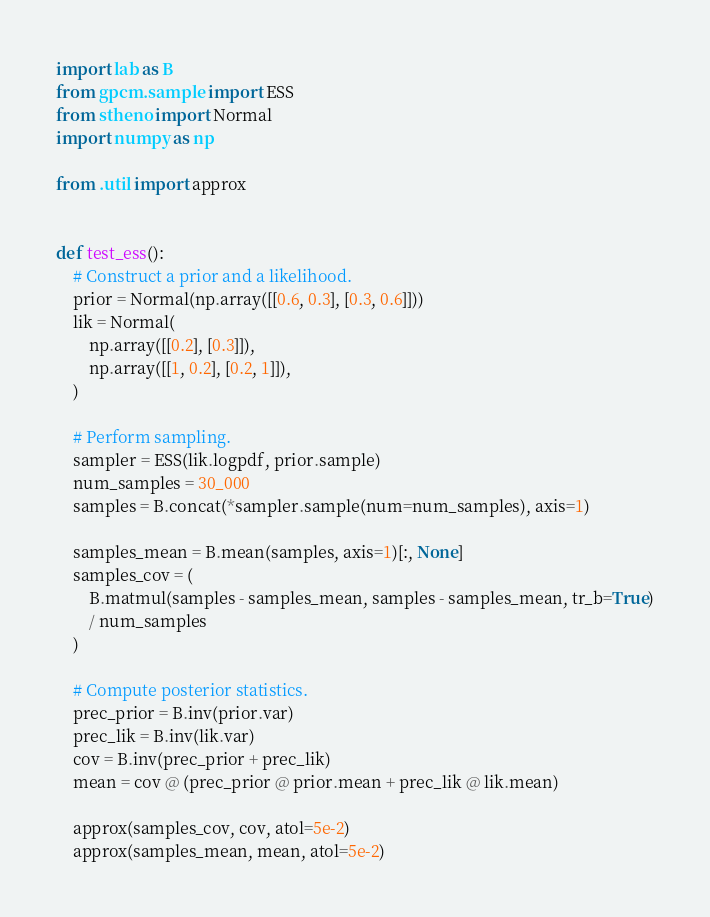Convert code to text. <code><loc_0><loc_0><loc_500><loc_500><_Python_>import lab as B
from gpcm.sample import ESS
from stheno import Normal
import numpy as np

from .util import approx


def test_ess():
    # Construct a prior and a likelihood.
    prior = Normal(np.array([[0.6, 0.3], [0.3, 0.6]]))
    lik = Normal(
        np.array([[0.2], [0.3]]),
        np.array([[1, 0.2], [0.2, 1]]),
    )

    # Perform sampling.
    sampler = ESS(lik.logpdf, prior.sample)
    num_samples = 30_000
    samples = B.concat(*sampler.sample(num=num_samples), axis=1)

    samples_mean = B.mean(samples, axis=1)[:, None]
    samples_cov = (
        B.matmul(samples - samples_mean, samples - samples_mean, tr_b=True)
        / num_samples
    )

    # Compute posterior statistics.
    prec_prior = B.inv(prior.var)
    prec_lik = B.inv(lik.var)
    cov = B.inv(prec_prior + prec_lik)
    mean = cov @ (prec_prior @ prior.mean + prec_lik @ lik.mean)

    approx(samples_cov, cov, atol=5e-2)
    approx(samples_mean, mean, atol=5e-2)
</code> 